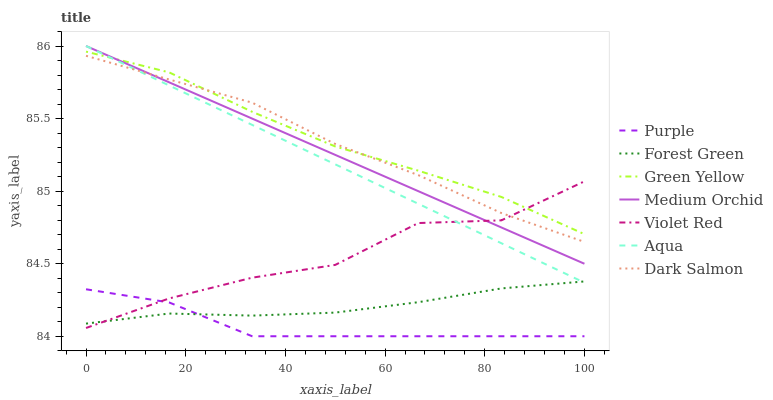Does Purple have the minimum area under the curve?
Answer yes or no. Yes. Does Green Yellow have the maximum area under the curve?
Answer yes or no. Yes. Does Medium Orchid have the minimum area under the curve?
Answer yes or no. No. Does Medium Orchid have the maximum area under the curve?
Answer yes or no. No. Is Medium Orchid the smoothest?
Answer yes or no. Yes. Is Violet Red the roughest?
Answer yes or no. Yes. Is Purple the smoothest?
Answer yes or no. No. Is Purple the roughest?
Answer yes or no. No. Does Purple have the lowest value?
Answer yes or no. Yes. Does Medium Orchid have the lowest value?
Answer yes or no. No. Does Aqua have the highest value?
Answer yes or no. Yes. Does Purple have the highest value?
Answer yes or no. No. Is Forest Green less than Medium Orchid?
Answer yes or no. Yes. Is Green Yellow greater than Forest Green?
Answer yes or no. Yes. Does Aqua intersect Dark Salmon?
Answer yes or no. Yes. Is Aqua less than Dark Salmon?
Answer yes or no. No. Is Aqua greater than Dark Salmon?
Answer yes or no. No. Does Forest Green intersect Medium Orchid?
Answer yes or no. No. 